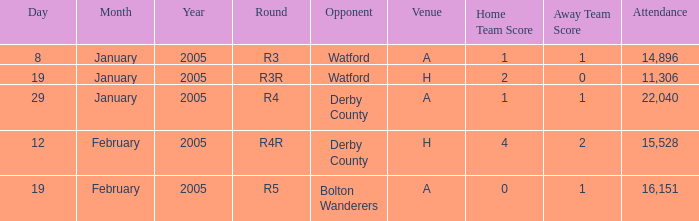Would you be able to parse every entry in this table? {'header': ['Day', 'Month', 'Year', 'Round', 'Opponent', 'Venue', 'Home Team Score', 'Away Team Score', 'Attendance'], 'rows': [['8', 'January', '2005', 'R3', 'Watford', 'A', '1', '1', '14,896'], ['19', 'January', '2005', 'R3R', 'Watford', 'H', '2', '0', '11,306'], ['29', 'January', '2005', 'R4', 'Derby County', 'A', '1', '1', '22,040'], ['12', 'February', '2005', 'R4R', 'Derby County', 'H', '4', '2', '15,528'], ['19', 'February', '2005', 'R5', 'Bolton Wanderers', 'A', '0', '1', '16,151']]} What is the date where the round is R3? 8 January 2005. 